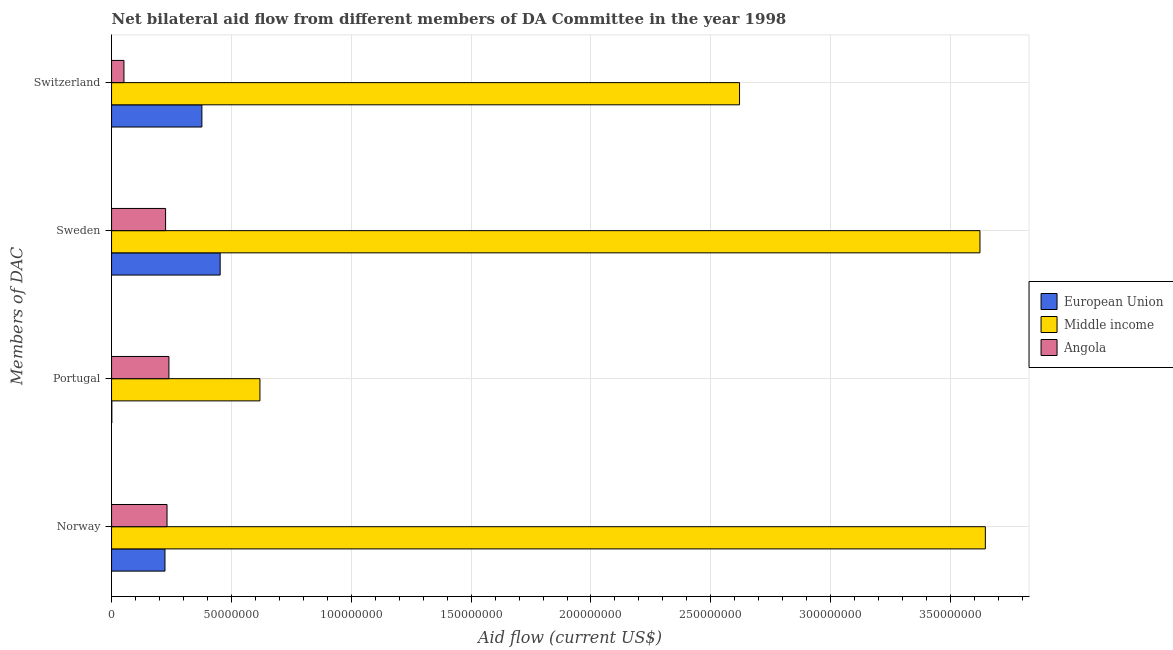How many groups of bars are there?
Offer a very short reply. 4. Are the number of bars per tick equal to the number of legend labels?
Provide a succinct answer. Yes. Are the number of bars on each tick of the Y-axis equal?
Your answer should be compact. Yes. How many bars are there on the 3rd tick from the top?
Offer a very short reply. 3. How many bars are there on the 2nd tick from the bottom?
Offer a very short reply. 3. What is the label of the 1st group of bars from the top?
Provide a succinct answer. Switzerland. What is the amount of aid given by switzerland in Middle income?
Offer a terse response. 2.62e+08. Across all countries, what is the maximum amount of aid given by portugal?
Provide a succinct answer. 6.19e+07. Across all countries, what is the minimum amount of aid given by sweden?
Keep it short and to the point. 2.25e+07. In which country was the amount of aid given by switzerland maximum?
Make the answer very short. Middle income. In which country was the amount of aid given by switzerland minimum?
Your response must be concise. Angola. What is the total amount of aid given by switzerland in the graph?
Provide a succinct answer. 3.05e+08. What is the difference between the amount of aid given by portugal in Middle income and that in Angola?
Your response must be concise. 3.80e+07. What is the difference between the amount of aid given by norway in Middle income and the amount of aid given by switzerland in European Union?
Provide a short and direct response. 3.27e+08. What is the average amount of aid given by portugal per country?
Ensure brevity in your answer.  2.86e+07. What is the difference between the amount of aid given by norway and amount of aid given by switzerland in Middle income?
Your answer should be very brief. 1.03e+08. What is the ratio of the amount of aid given by switzerland in Middle income to that in Angola?
Provide a short and direct response. 50.67. Is the amount of aid given by switzerland in Middle income less than that in Angola?
Provide a short and direct response. No. Is the difference between the amount of aid given by portugal in European Union and Angola greater than the difference between the amount of aid given by sweden in European Union and Angola?
Offer a terse response. No. What is the difference between the highest and the second highest amount of aid given by switzerland?
Make the answer very short. 2.24e+08. What is the difference between the highest and the lowest amount of aid given by norway?
Provide a short and direct response. 3.42e+08. In how many countries, is the amount of aid given by portugal greater than the average amount of aid given by portugal taken over all countries?
Your answer should be compact. 1. Is the sum of the amount of aid given by sweden in Angola and European Union greater than the maximum amount of aid given by switzerland across all countries?
Make the answer very short. No. What does the 1st bar from the bottom in Switzerland represents?
Offer a terse response. European Union. How many bars are there?
Offer a terse response. 12. Are all the bars in the graph horizontal?
Ensure brevity in your answer.  Yes. What is the difference between two consecutive major ticks on the X-axis?
Give a very brief answer. 5.00e+07. Does the graph contain grids?
Give a very brief answer. Yes. Where does the legend appear in the graph?
Offer a terse response. Center right. How many legend labels are there?
Your answer should be compact. 3. What is the title of the graph?
Provide a short and direct response. Net bilateral aid flow from different members of DA Committee in the year 1998. Does "Libya" appear as one of the legend labels in the graph?
Make the answer very short. No. What is the label or title of the Y-axis?
Ensure brevity in your answer.  Members of DAC. What is the Aid flow (current US$) in European Union in Norway?
Offer a very short reply. 2.23e+07. What is the Aid flow (current US$) of Middle income in Norway?
Your response must be concise. 3.65e+08. What is the Aid flow (current US$) of Angola in Norway?
Provide a succinct answer. 2.31e+07. What is the Aid flow (current US$) of European Union in Portugal?
Offer a terse response. 1.20e+05. What is the Aid flow (current US$) of Middle income in Portugal?
Offer a terse response. 6.19e+07. What is the Aid flow (current US$) in Angola in Portugal?
Ensure brevity in your answer.  2.39e+07. What is the Aid flow (current US$) of European Union in Sweden?
Make the answer very short. 4.53e+07. What is the Aid flow (current US$) of Middle income in Sweden?
Ensure brevity in your answer.  3.62e+08. What is the Aid flow (current US$) of Angola in Sweden?
Make the answer very short. 2.25e+07. What is the Aid flow (current US$) of European Union in Switzerland?
Ensure brevity in your answer.  3.77e+07. What is the Aid flow (current US$) in Middle income in Switzerland?
Provide a succinct answer. 2.62e+08. What is the Aid flow (current US$) in Angola in Switzerland?
Give a very brief answer. 5.17e+06. Across all Members of DAC, what is the maximum Aid flow (current US$) of European Union?
Offer a very short reply. 4.53e+07. Across all Members of DAC, what is the maximum Aid flow (current US$) in Middle income?
Provide a short and direct response. 3.65e+08. Across all Members of DAC, what is the maximum Aid flow (current US$) in Angola?
Provide a short and direct response. 2.39e+07. Across all Members of DAC, what is the minimum Aid flow (current US$) of European Union?
Keep it short and to the point. 1.20e+05. Across all Members of DAC, what is the minimum Aid flow (current US$) of Middle income?
Offer a very short reply. 6.19e+07. Across all Members of DAC, what is the minimum Aid flow (current US$) in Angola?
Your answer should be compact. 5.17e+06. What is the total Aid flow (current US$) in European Union in the graph?
Offer a terse response. 1.05e+08. What is the total Aid flow (current US$) in Middle income in the graph?
Ensure brevity in your answer.  1.05e+09. What is the total Aid flow (current US$) in Angola in the graph?
Provide a short and direct response. 7.48e+07. What is the difference between the Aid flow (current US$) of European Union in Norway and that in Portugal?
Ensure brevity in your answer.  2.22e+07. What is the difference between the Aid flow (current US$) in Middle income in Norway and that in Portugal?
Ensure brevity in your answer.  3.03e+08. What is the difference between the Aid flow (current US$) of Angola in Norway and that in Portugal?
Keep it short and to the point. -7.90e+05. What is the difference between the Aid flow (current US$) in European Union in Norway and that in Sweden?
Your answer should be very brief. -2.30e+07. What is the difference between the Aid flow (current US$) in Middle income in Norway and that in Sweden?
Give a very brief answer. 2.25e+06. What is the difference between the Aid flow (current US$) of European Union in Norway and that in Switzerland?
Your response must be concise. -1.54e+07. What is the difference between the Aid flow (current US$) of Middle income in Norway and that in Switzerland?
Provide a succinct answer. 1.03e+08. What is the difference between the Aid flow (current US$) of Angola in Norway and that in Switzerland?
Provide a succinct answer. 1.80e+07. What is the difference between the Aid flow (current US$) in European Union in Portugal and that in Sweden?
Offer a very short reply. -4.52e+07. What is the difference between the Aid flow (current US$) of Middle income in Portugal and that in Sweden?
Offer a terse response. -3.00e+08. What is the difference between the Aid flow (current US$) of Angola in Portugal and that in Sweden?
Offer a terse response. 1.39e+06. What is the difference between the Aid flow (current US$) of European Union in Portugal and that in Switzerland?
Provide a succinct answer. -3.76e+07. What is the difference between the Aid flow (current US$) in Middle income in Portugal and that in Switzerland?
Keep it short and to the point. -2.00e+08. What is the difference between the Aid flow (current US$) in Angola in Portugal and that in Switzerland?
Your response must be concise. 1.88e+07. What is the difference between the Aid flow (current US$) in European Union in Sweden and that in Switzerland?
Ensure brevity in your answer.  7.62e+06. What is the difference between the Aid flow (current US$) in Middle income in Sweden and that in Switzerland?
Give a very brief answer. 1.00e+08. What is the difference between the Aid flow (current US$) of Angola in Sweden and that in Switzerland?
Keep it short and to the point. 1.74e+07. What is the difference between the Aid flow (current US$) in European Union in Norway and the Aid flow (current US$) in Middle income in Portugal?
Keep it short and to the point. -3.96e+07. What is the difference between the Aid flow (current US$) of European Union in Norway and the Aid flow (current US$) of Angola in Portugal?
Make the answer very short. -1.65e+06. What is the difference between the Aid flow (current US$) of Middle income in Norway and the Aid flow (current US$) of Angola in Portugal?
Give a very brief answer. 3.41e+08. What is the difference between the Aid flow (current US$) of European Union in Norway and the Aid flow (current US$) of Middle income in Sweden?
Your response must be concise. -3.40e+08. What is the difference between the Aid flow (current US$) in European Union in Norway and the Aid flow (current US$) in Angola in Sweden?
Ensure brevity in your answer.  -2.60e+05. What is the difference between the Aid flow (current US$) in Middle income in Norway and the Aid flow (current US$) in Angola in Sweden?
Ensure brevity in your answer.  3.42e+08. What is the difference between the Aid flow (current US$) of European Union in Norway and the Aid flow (current US$) of Middle income in Switzerland?
Offer a terse response. -2.40e+08. What is the difference between the Aid flow (current US$) of European Union in Norway and the Aid flow (current US$) of Angola in Switzerland?
Provide a succinct answer. 1.71e+07. What is the difference between the Aid flow (current US$) in Middle income in Norway and the Aid flow (current US$) in Angola in Switzerland?
Offer a terse response. 3.59e+08. What is the difference between the Aid flow (current US$) in European Union in Portugal and the Aid flow (current US$) in Middle income in Sweden?
Your response must be concise. -3.62e+08. What is the difference between the Aid flow (current US$) in European Union in Portugal and the Aid flow (current US$) in Angola in Sweden?
Provide a succinct answer. -2.24e+07. What is the difference between the Aid flow (current US$) in Middle income in Portugal and the Aid flow (current US$) in Angola in Sweden?
Keep it short and to the point. 3.94e+07. What is the difference between the Aid flow (current US$) of European Union in Portugal and the Aid flow (current US$) of Middle income in Switzerland?
Offer a very short reply. -2.62e+08. What is the difference between the Aid flow (current US$) of European Union in Portugal and the Aid flow (current US$) of Angola in Switzerland?
Ensure brevity in your answer.  -5.05e+06. What is the difference between the Aid flow (current US$) of Middle income in Portugal and the Aid flow (current US$) of Angola in Switzerland?
Your response must be concise. 5.67e+07. What is the difference between the Aid flow (current US$) in European Union in Sweden and the Aid flow (current US$) in Middle income in Switzerland?
Your answer should be compact. -2.17e+08. What is the difference between the Aid flow (current US$) in European Union in Sweden and the Aid flow (current US$) in Angola in Switzerland?
Ensure brevity in your answer.  4.01e+07. What is the difference between the Aid flow (current US$) in Middle income in Sweden and the Aid flow (current US$) in Angola in Switzerland?
Ensure brevity in your answer.  3.57e+08. What is the average Aid flow (current US$) of European Union per Members of DAC?
Ensure brevity in your answer.  2.63e+07. What is the average Aid flow (current US$) of Middle income per Members of DAC?
Your answer should be compact. 2.63e+08. What is the average Aid flow (current US$) in Angola per Members of DAC?
Your response must be concise. 1.87e+07. What is the difference between the Aid flow (current US$) of European Union and Aid flow (current US$) of Middle income in Norway?
Offer a very short reply. -3.42e+08. What is the difference between the Aid flow (current US$) of European Union and Aid flow (current US$) of Angola in Norway?
Your answer should be compact. -8.60e+05. What is the difference between the Aid flow (current US$) of Middle income and Aid flow (current US$) of Angola in Norway?
Offer a very short reply. 3.41e+08. What is the difference between the Aid flow (current US$) in European Union and Aid flow (current US$) in Middle income in Portugal?
Provide a short and direct response. -6.18e+07. What is the difference between the Aid flow (current US$) in European Union and Aid flow (current US$) in Angola in Portugal?
Ensure brevity in your answer.  -2.38e+07. What is the difference between the Aid flow (current US$) in Middle income and Aid flow (current US$) in Angola in Portugal?
Your response must be concise. 3.80e+07. What is the difference between the Aid flow (current US$) in European Union and Aid flow (current US$) in Middle income in Sweden?
Keep it short and to the point. -3.17e+08. What is the difference between the Aid flow (current US$) in European Union and Aid flow (current US$) in Angola in Sweden?
Ensure brevity in your answer.  2.28e+07. What is the difference between the Aid flow (current US$) in Middle income and Aid flow (current US$) in Angola in Sweden?
Keep it short and to the point. 3.40e+08. What is the difference between the Aid flow (current US$) in European Union and Aid flow (current US$) in Middle income in Switzerland?
Offer a terse response. -2.24e+08. What is the difference between the Aid flow (current US$) of European Union and Aid flow (current US$) of Angola in Switzerland?
Ensure brevity in your answer.  3.25e+07. What is the difference between the Aid flow (current US$) of Middle income and Aid flow (current US$) of Angola in Switzerland?
Keep it short and to the point. 2.57e+08. What is the ratio of the Aid flow (current US$) of European Union in Norway to that in Portugal?
Provide a succinct answer. 185.67. What is the ratio of the Aid flow (current US$) in Middle income in Norway to that in Portugal?
Make the answer very short. 5.89. What is the ratio of the Aid flow (current US$) of Angola in Norway to that in Portugal?
Ensure brevity in your answer.  0.97. What is the ratio of the Aid flow (current US$) in European Union in Norway to that in Sweden?
Make the answer very short. 0.49. What is the ratio of the Aid flow (current US$) of Angola in Norway to that in Sweden?
Provide a succinct answer. 1.03. What is the ratio of the Aid flow (current US$) in European Union in Norway to that in Switzerland?
Your answer should be very brief. 0.59. What is the ratio of the Aid flow (current US$) of Middle income in Norway to that in Switzerland?
Give a very brief answer. 1.39. What is the ratio of the Aid flow (current US$) in Angola in Norway to that in Switzerland?
Offer a very short reply. 4.48. What is the ratio of the Aid flow (current US$) in European Union in Portugal to that in Sweden?
Your response must be concise. 0. What is the ratio of the Aid flow (current US$) in Middle income in Portugal to that in Sweden?
Provide a short and direct response. 0.17. What is the ratio of the Aid flow (current US$) in Angola in Portugal to that in Sweden?
Make the answer very short. 1.06. What is the ratio of the Aid flow (current US$) of European Union in Portugal to that in Switzerland?
Offer a terse response. 0. What is the ratio of the Aid flow (current US$) of Middle income in Portugal to that in Switzerland?
Ensure brevity in your answer.  0.24. What is the ratio of the Aid flow (current US$) in Angola in Portugal to that in Switzerland?
Your answer should be compact. 4.63. What is the ratio of the Aid flow (current US$) of European Union in Sweden to that in Switzerland?
Ensure brevity in your answer.  1.2. What is the ratio of the Aid flow (current US$) of Middle income in Sweden to that in Switzerland?
Make the answer very short. 1.38. What is the ratio of the Aid flow (current US$) in Angola in Sweden to that in Switzerland?
Your answer should be very brief. 4.36. What is the difference between the highest and the second highest Aid flow (current US$) in European Union?
Make the answer very short. 7.62e+06. What is the difference between the highest and the second highest Aid flow (current US$) of Middle income?
Your answer should be very brief. 2.25e+06. What is the difference between the highest and the second highest Aid flow (current US$) in Angola?
Ensure brevity in your answer.  7.90e+05. What is the difference between the highest and the lowest Aid flow (current US$) in European Union?
Your answer should be very brief. 4.52e+07. What is the difference between the highest and the lowest Aid flow (current US$) in Middle income?
Make the answer very short. 3.03e+08. What is the difference between the highest and the lowest Aid flow (current US$) of Angola?
Your response must be concise. 1.88e+07. 